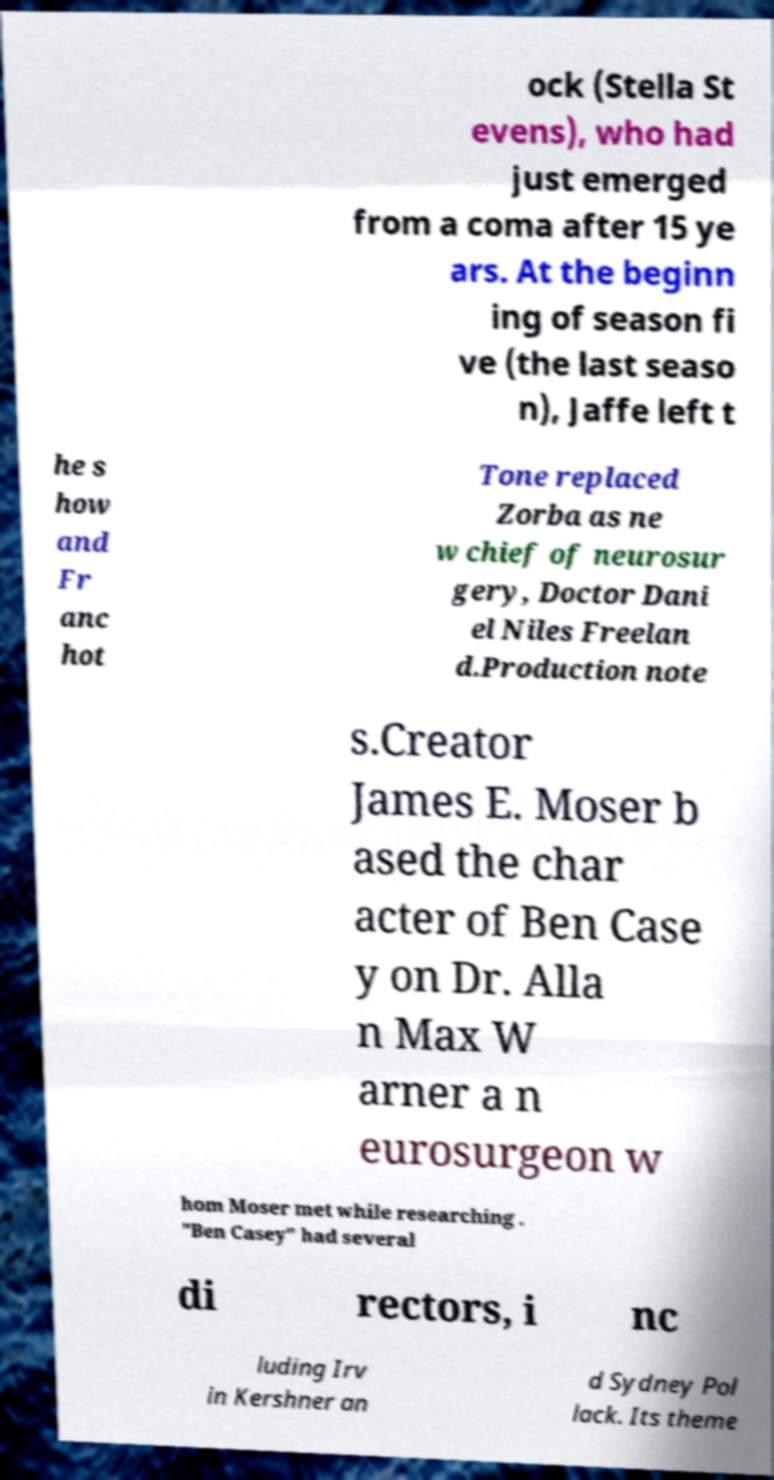Could you assist in decoding the text presented in this image and type it out clearly? ock (Stella St evens), who had just emerged from a coma after 15 ye ars. At the beginn ing of season fi ve (the last seaso n), Jaffe left t he s how and Fr anc hot Tone replaced Zorba as ne w chief of neurosur gery, Doctor Dani el Niles Freelan d.Production note s.Creator James E. Moser b ased the char acter of Ben Case y on Dr. Alla n Max W arner a n eurosurgeon w hom Moser met while researching . "Ben Casey" had several di rectors, i nc luding Irv in Kershner an d Sydney Pol lack. Its theme 